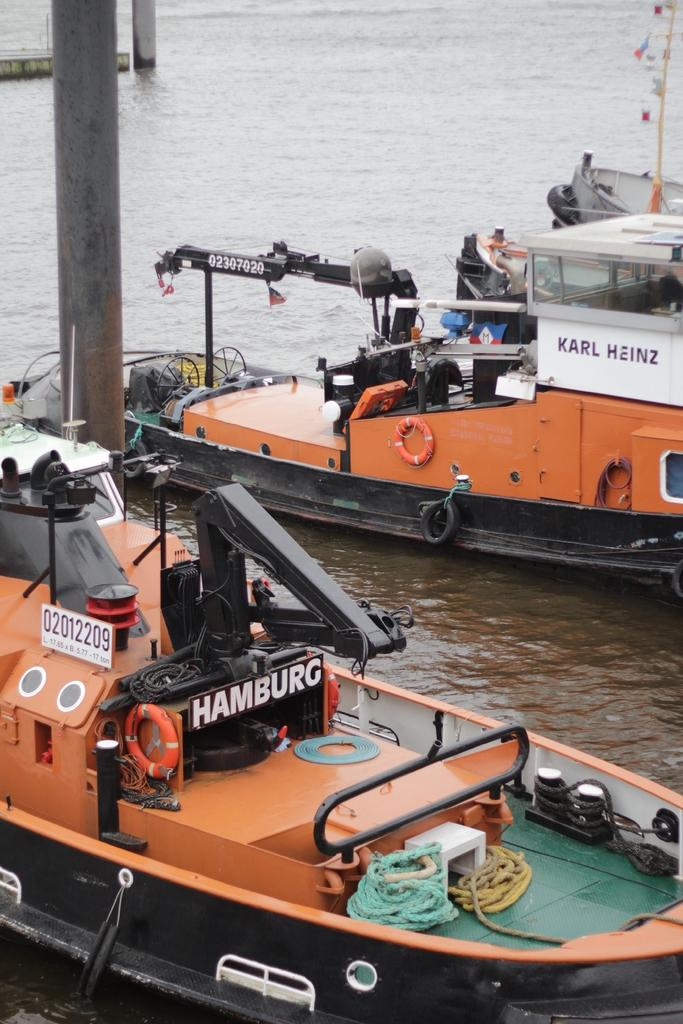What is on the water in the image? There are boats on the water in the image. What can be found inside the boats? There are ropes and other objects in the boats. What structures are visible in the image? There are poles visible in the image. What type of blade can be seen cutting through the water in the image? There is no blade cutting through the water in the image; it features boats on the water with ropes and objects inside them, and poles visible. 